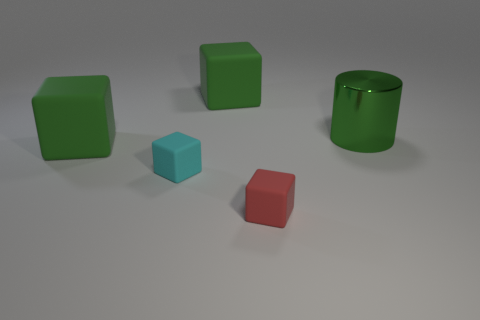Add 1 gray shiny spheres. How many objects exist? 6 Subtract all small cyan matte blocks. How many blocks are left? 3 Subtract all purple cylinders. How many green blocks are left? 2 Subtract all cyan cubes. How many cubes are left? 3 Subtract all cylinders. How many objects are left? 4 Subtract all small matte things. Subtract all large purple blocks. How many objects are left? 3 Add 3 small cyan matte blocks. How many small cyan matte blocks are left? 4 Add 4 tiny red rubber things. How many tiny red rubber things exist? 5 Subtract 0 brown cubes. How many objects are left? 5 Subtract all blue blocks. Subtract all gray spheres. How many blocks are left? 4 